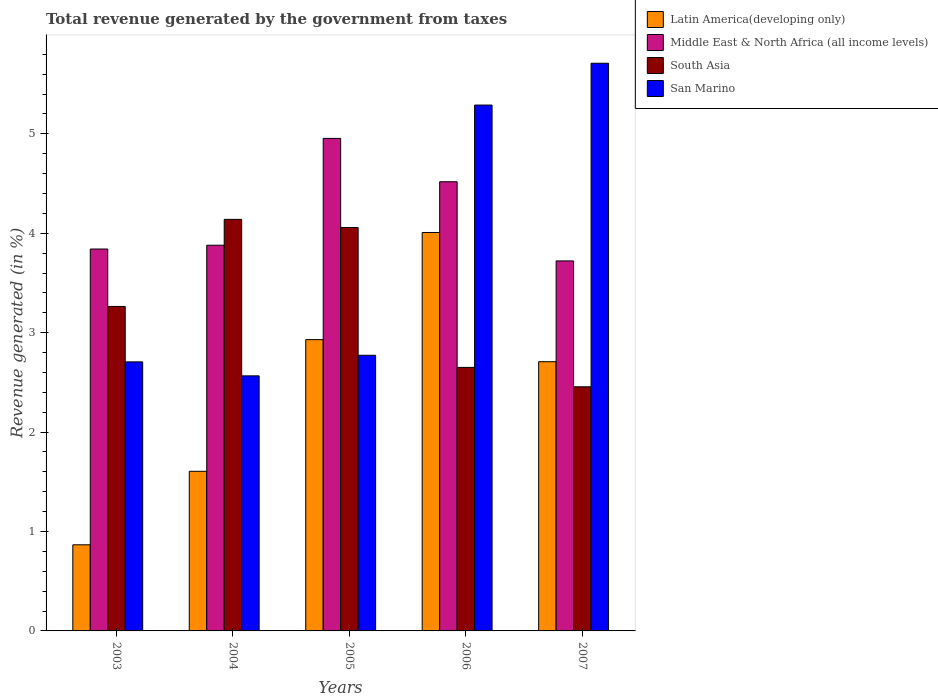How many different coloured bars are there?
Give a very brief answer. 4. How many groups of bars are there?
Keep it short and to the point. 5. Are the number of bars on each tick of the X-axis equal?
Provide a succinct answer. Yes. How many bars are there on the 1st tick from the right?
Offer a very short reply. 4. What is the label of the 4th group of bars from the left?
Your answer should be very brief. 2006. What is the total revenue generated in South Asia in 2007?
Provide a succinct answer. 2.46. Across all years, what is the maximum total revenue generated in Middle East & North Africa (all income levels)?
Provide a succinct answer. 4.95. Across all years, what is the minimum total revenue generated in San Marino?
Give a very brief answer. 2.57. What is the total total revenue generated in San Marino in the graph?
Your answer should be very brief. 19.04. What is the difference between the total revenue generated in San Marino in 2006 and that in 2007?
Your answer should be compact. -0.42. What is the difference between the total revenue generated in Latin America(developing only) in 2005 and the total revenue generated in Middle East & North Africa (all income levels) in 2006?
Ensure brevity in your answer.  -1.59. What is the average total revenue generated in South Asia per year?
Your answer should be compact. 3.31. In the year 2006, what is the difference between the total revenue generated in Middle East & North Africa (all income levels) and total revenue generated in South Asia?
Provide a short and direct response. 1.87. In how many years, is the total revenue generated in South Asia greater than 3 %?
Your answer should be compact. 3. What is the ratio of the total revenue generated in South Asia in 2003 to that in 2006?
Your answer should be compact. 1.23. Is the total revenue generated in South Asia in 2006 less than that in 2007?
Provide a succinct answer. No. Is the difference between the total revenue generated in Middle East & North Africa (all income levels) in 2003 and 2007 greater than the difference between the total revenue generated in South Asia in 2003 and 2007?
Ensure brevity in your answer.  No. What is the difference between the highest and the second highest total revenue generated in Middle East & North Africa (all income levels)?
Provide a succinct answer. 0.44. What is the difference between the highest and the lowest total revenue generated in Latin America(developing only)?
Ensure brevity in your answer.  3.14. In how many years, is the total revenue generated in Latin America(developing only) greater than the average total revenue generated in Latin America(developing only) taken over all years?
Your response must be concise. 3. What does the 3rd bar from the left in 2005 represents?
Provide a short and direct response. South Asia. What does the 3rd bar from the right in 2003 represents?
Ensure brevity in your answer.  Middle East & North Africa (all income levels). Does the graph contain grids?
Ensure brevity in your answer.  No. Where does the legend appear in the graph?
Offer a very short reply. Top right. How many legend labels are there?
Keep it short and to the point. 4. How are the legend labels stacked?
Give a very brief answer. Vertical. What is the title of the graph?
Provide a succinct answer. Total revenue generated by the government from taxes. What is the label or title of the X-axis?
Provide a succinct answer. Years. What is the label or title of the Y-axis?
Ensure brevity in your answer.  Revenue generated (in %). What is the Revenue generated (in %) in Latin America(developing only) in 2003?
Ensure brevity in your answer.  0.87. What is the Revenue generated (in %) of Middle East & North Africa (all income levels) in 2003?
Offer a very short reply. 3.84. What is the Revenue generated (in %) of South Asia in 2003?
Offer a terse response. 3.26. What is the Revenue generated (in %) of San Marino in 2003?
Your response must be concise. 2.71. What is the Revenue generated (in %) in Latin America(developing only) in 2004?
Offer a very short reply. 1.61. What is the Revenue generated (in %) of Middle East & North Africa (all income levels) in 2004?
Keep it short and to the point. 3.88. What is the Revenue generated (in %) in South Asia in 2004?
Your answer should be very brief. 4.14. What is the Revenue generated (in %) in San Marino in 2004?
Make the answer very short. 2.57. What is the Revenue generated (in %) in Latin America(developing only) in 2005?
Give a very brief answer. 2.93. What is the Revenue generated (in %) in Middle East & North Africa (all income levels) in 2005?
Offer a terse response. 4.95. What is the Revenue generated (in %) in South Asia in 2005?
Keep it short and to the point. 4.06. What is the Revenue generated (in %) of San Marino in 2005?
Offer a very short reply. 2.77. What is the Revenue generated (in %) in Latin America(developing only) in 2006?
Your response must be concise. 4.01. What is the Revenue generated (in %) in Middle East & North Africa (all income levels) in 2006?
Provide a succinct answer. 4.52. What is the Revenue generated (in %) of South Asia in 2006?
Your answer should be compact. 2.65. What is the Revenue generated (in %) of San Marino in 2006?
Ensure brevity in your answer.  5.29. What is the Revenue generated (in %) of Latin America(developing only) in 2007?
Offer a terse response. 2.71. What is the Revenue generated (in %) of Middle East & North Africa (all income levels) in 2007?
Offer a very short reply. 3.72. What is the Revenue generated (in %) of South Asia in 2007?
Provide a succinct answer. 2.46. What is the Revenue generated (in %) in San Marino in 2007?
Keep it short and to the point. 5.71. Across all years, what is the maximum Revenue generated (in %) in Latin America(developing only)?
Make the answer very short. 4.01. Across all years, what is the maximum Revenue generated (in %) in Middle East & North Africa (all income levels)?
Provide a short and direct response. 4.95. Across all years, what is the maximum Revenue generated (in %) in South Asia?
Your response must be concise. 4.14. Across all years, what is the maximum Revenue generated (in %) in San Marino?
Offer a very short reply. 5.71. Across all years, what is the minimum Revenue generated (in %) of Latin America(developing only)?
Your answer should be compact. 0.87. Across all years, what is the minimum Revenue generated (in %) of Middle East & North Africa (all income levels)?
Your answer should be compact. 3.72. Across all years, what is the minimum Revenue generated (in %) in South Asia?
Your response must be concise. 2.46. Across all years, what is the minimum Revenue generated (in %) of San Marino?
Offer a terse response. 2.57. What is the total Revenue generated (in %) of Latin America(developing only) in the graph?
Give a very brief answer. 12.12. What is the total Revenue generated (in %) in Middle East & North Africa (all income levels) in the graph?
Keep it short and to the point. 20.92. What is the total Revenue generated (in %) in South Asia in the graph?
Make the answer very short. 16.57. What is the total Revenue generated (in %) in San Marino in the graph?
Give a very brief answer. 19.04. What is the difference between the Revenue generated (in %) of Latin America(developing only) in 2003 and that in 2004?
Give a very brief answer. -0.74. What is the difference between the Revenue generated (in %) of Middle East & North Africa (all income levels) in 2003 and that in 2004?
Your answer should be compact. -0.04. What is the difference between the Revenue generated (in %) in South Asia in 2003 and that in 2004?
Provide a succinct answer. -0.88. What is the difference between the Revenue generated (in %) in San Marino in 2003 and that in 2004?
Your response must be concise. 0.14. What is the difference between the Revenue generated (in %) of Latin America(developing only) in 2003 and that in 2005?
Your response must be concise. -2.06. What is the difference between the Revenue generated (in %) in Middle East & North Africa (all income levels) in 2003 and that in 2005?
Your answer should be compact. -1.11. What is the difference between the Revenue generated (in %) in South Asia in 2003 and that in 2005?
Your answer should be compact. -0.79. What is the difference between the Revenue generated (in %) of San Marino in 2003 and that in 2005?
Provide a short and direct response. -0.07. What is the difference between the Revenue generated (in %) of Latin America(developing only) in 2003 and that in 2006?
Offer a terse response. -3.14. What is the difference between the Revenue generated (in %) of Middle East & North Africa (all income levels) in 2003 and that in 2006?
Make the answer very short. -0.68. What is the difference between the Revenue generated (in %) of South Asia in 2003 and that in 2006?
Keep it short and to the point. 0.61. What is the difference between the Revenue generated (in %) of San Marino in 2003 and that in 2006?
Give a very brief answer. -2.58. What is the difference between the Revenue generated (in %) in Latin America(developing only) in 2003 and that in 2007?
Provide a short and direct response. -1.84. What is the difference between the Revenue generated (in %) of Middle East & North Africa (all income levels) in 2003 and that in 2007?
Your answer should be compact. 0.12. What is the difference between the Revenue generated (in %) of South Asia in 2003 and that in 2007?
Your answer should be very brief. 0.81. What is the difference between the Revenue generated (in %) in San Marino in 2003 and that in 2007?
Your response must be concise. -3. What is the difference between the Revenue generated (in %) in Latin America(developing only) in 2004 and that in 2005?
Offer a very short reply. -1.32. What is the difference between the Revenue generated (in %) of Middle East & North Africa (all income levels) in 2004 and that in 2005?
Ensure brevity in your answer.  -1.07. What is the difference between the Revenue generated (in %) in South Asia in 2004 and that in 2005?
Give a very brief answer. 0.08. What is the difference between the Revenue generated (in %) in San Marino in 2004 and that in 2005?
Ensure brevity in your answer.  -0.21. What is the difference between the Revenue generated (in %) in Latin America(developing only) in 2004 and that in 2006?
Make the answer very short. -2.4. What is the difference between the Revenue generated (in %) in Middle East & North Africa (all income levels) in 2004 and that in 2006?
Make the answer very short. -0.64. What is the difference between the Revenue generated (in %) of South Asia in 2004 and that in 2006?
Offer a very short reply. 1.49. What is the difference between the Revenue generated (in %) in San Marino in 2004 and that in 2006?
Keep it short and to the point. -2.72. What is the difference between the Revenue generated (in %) in Latin America(developing only) in 2004 and that in 2007?
Ensure brevity in your answer.  -1.1. What is the difference between the Revenue generated (in %) of Middle East & North Africa (all income levels) in 2004 and that in 2007?
Offer a very short reply. 0.16. What is the difference between the Revenue generated (in %) of South Asia in 2004 and that in 2007?
Keep it short and to the point. 1.68. What is the difference between the Revenue generated (in %) of San Marino in 2004 and that in 2007?
Offer a very short reply. -3.14. What is the difference between the Revenue generated (in %) in Latin America(developing only) in 2005 and that in 2006?
Make the answer very short. -1.08. What is the difference between the Revenue generated (in %) in Middle East & North Africa (all income levels) in 2005 and that in 2006?
Your answer should be compact. 0.44. What is the difference between the Revenue generated (in %) of South Asia in 2005 and that in 2006?
Your answer should be very brief. 1.41. What is the difference between the Revenue generated (in %) of San Marino in 2005 and that in 2006?
Your answer should be very brief. -2.52. What is the difference between the Revenue generated (in %) in Latin America(developing only) in 2005 and that in 2007?
Give a very brief answer. 0.22. What is the difference between the Revenue generated (in %) in Middle East & North Africa (all income levels) in 2005 and that in 2007?
Your answer should be very brief. 1.23. What is the difference between the Revenue generated (in %) of South Asia in 2005 and that in 2007?
Keep it short and to the point. 1.6. What is the difference between the Revenue generated (in %) in San Marino in 2005 and that in 2007?
Offer a terse response. -2.94. What is the difference between the Revenue generated (in %) in Latin America(developing only) in 2006 and that in 2007?
Keep it short and to the point. 1.3. What is the difference between the Revenue generated (in %) of Middle East & North Africa (all income levels) in 2006 and that in 2007?
Your answer should be compact. 0.8. What is the difference between the Revenue generated (in %) in South Asia in 2006 and that in 2007?
Offer a terse response. 0.2. What is the difference between the Revenue generated (in %) of San Marino in 2006 and that in 2007?
Offer a very short reply. -0.42. What is the difference between the Revenue generated (in %) of Latin America(developing only) in 2003 and the Revenue generated (in %) of Middle East & North Africa (all income levels) in 2004?
Ensure brevity in your answer.  -3.01. What is the difference between the Revenue generated (in %) of Latin America(developing only) in 2003 and the Revenue generated (in %) of South Asia in 2004?
Provide a short and direct response. -3.27. What is the difference between the Revenue generated (in %) in Latin America(developing only) in 2003 and the Revenue generated (in %) in San Marino in 2004?
Ensure brevity in your answer.  -1.7. What is the difference between the Revenue generated (in %) of Middle East & North Africa (all income levels) in 2003 and the Revenue generated (in %) of South Asia in 2004?
Provide a short and direct response. -0.3. What is the difference between the Revenue generated (in %) in Middle East & North Africa (all income levels) in 2003 and the Revenue generated (in %) in San Marino in 2004?
Make the answer very short. 1.28. What is the difference between the Revenue generated (in %) of South Asia in 2003 and the Revenue generated (in %) of San Marino in 2004?
Your answer should be compact. 0.7. What is the difference between the Revenue generated (in %) of Latin America(developing only) in 2003 and the Revenue generated (in %) of Middle East & North Africa (all income levels) in 2005?
Your answer should be compact. -4.09. What is the difference between the Revenue generated (in %) of Latin America(developing only) in 2003 and the Revenue generated (in %) of South Asia in 2005?
Provide a succinct answer. -3.19. What is the difference between the Revenue generated (in %) in Latin America(developing only) in 2003 and the Revenue generated (in %) in San Marino in 2005?
Your answer should be compact. -1.91. What is the difference between the Revenue generated (in %) in Middle East & North Africa (all income levels) in 2003 and the Revenue generated (in %) in South Asia in 2005?
Provide a succinct answer. -0.22. What is the difference between the Revenue generated (in %) in Middle East & North Africa (all income levels) in 2003 and the Revenue generated (in %) in San Marino in 2005?
Your response must be concise. 1.07. What is the difference between the Revenue generated (in %) in South Asia in 2003 and the Revenue generated (in %) in San Marino in 2005?
Ensure brevity in your answer.  0.49. What is the difference between the Revenue generated (in %) of Latin America(developing only) in 2003 and the Revenue generated (in %) of Middle East & North Africa (all income levels) in 2006?
Provide a short and direct response. -3.65. What is the difference between the Revenue generated (in %) of Latin America(developing only) in 2003 and the Revenue generated (in %) of South Asia in 2006?
Give a very brief answer. -1.78. What is the difference between the Revenue generated (in %) in Latin America(developing only) in 2003 and the Revenue generated (in %) in San Marino in 2006?
Offer a terse response. -4.42. What is the difference between the Revenue generated (in %) of Middle East & North Africa (all income levels) in 2003 and the Revenue generated (in %) of South Asia in 2006?
Keep it short and to the point. 1.19. What is the difference between the Revenue generated (in %) of Middle East & North Africa (all income levels) in 2003 and the Revenue generated (in %) of San Marino in 2006?
Make the answer very short. -1.45. What is the difference between the Revenue generated (in %) in South Asia in 2003 and the Revenue generated (in %) in San Marino in 2006?
Ensure brevity in your answer.  -2.03. What is the difference between the Revenue generated (in %) of Latin America(developing only) in 2003 and the Revenue generated (in %) of Middle East & North Africa (all income levels) in 2007?
Ensure brevity in your answer.  -2.86. What is the difference between the Revenue generated (in %) of Latin America(developing only) in 2003 and the Revenue generated (in %) of South Asia in 2007?
Offer a terse response. -1.59. What is the difference between the Revenue generated (in %) of Latin America(developing only) in 2003 and the Revenue generated (in %) of San Marino in 2007?
Make the answer very short. -4.84. What is the difference between the Revenue generated (in %) of Middle East & North Africa (all income levels) in 2003 and the Revenue generated (in %) of South Asia in 2007?
Ensure brevity in your answer.  1.39. What is the difference between the Revenue generated (in %) of Middle East & North Africa (all income levels) in 2003 and the Revenue generated (in %) of San Marino in 2007?
Your answer should be very brief. -1.87. What is the difference between the Revenue generated (in %) of South Asia in 2003 and the Revenue generated (in %) of San Marino in 2007?
Your response must be concise. -2.45. What is the difference between the Revenue generated (in %) in Latin America(developing only) in 2004 and the Revenue generated (in %) in Middle East & North Africa (all income levels) in 2005?
Your answer should be very brief. -3.35. What is the difference between the Revenue generated (in %) of Latin America(developing only) in 2004 and the Revenue generated (in %) of South Asia in 2005?
Provide a short and direct response. -2.45. What is the difference between the Revenue generated (in %) of Latin America(developing only) in 2004 and the Revenue generated (in %) of San Marino in 2005?
Make the answer very short. -1.17. What is the difference between the Revenue generated (in %) in Middle East & North Africa (all income levels) in 2004 and the Revenue generated (in %) in South Asia in 2005?
Offer a very short reply. -0.18. What is the difference between the Revenue generated (in %) in Middle East & North Africa (all income levels) in 2004 and the Revenue generated (in %) in San Marino in 2005?
Give a very brief answer. 1.11. What is the difference between the Revenue generated (in %) of South Asia in 2004 and the Revenue generated (in %) of San Marino in 2005?
Provide a succinct answer. 1.37. What is the difference between the Revenue generated (in %) of Latin America(developing only) in 2004 and the Revenue generated (in %) of Middle East & North Africa (all income levels) in 2006?
Your answer should be very brief. -2.91. What is the difference between the Revenue generated (in %) of Latin America(developing only) in 2004 and the Revenue generated (in %) of South Asia in 2006?
Keep it short and to the point. -1.05. What is the difference between the Revenue generated (in %) of Latin America(developing only) in 2004 and the Revenue generated (in %) of San Marino in 2006?
Keep it short and to the point. -3.68. What is the difference between the Revenue generated (in %) in Middle East & North Africa (all income levels) in 2004 and the Revenue generated (in %) in South Asia in 2006?
Provide a short and direct response. 1.23. What is the difference between the Revenue generated (in %) of Middle East & North Africa (all income levels) in 2004 and the Revenue generated (in %) of San Marino in 2006?
Make the answer very short. -1.41. What is the difference between the Revenue generated (in %) of South Asia in 2004 and the Revenue generated (in %) of San Marino in 2006?
Your response must be concise. -1.15. What is the difference between the Revenue generated (in %) in Latin America(developing only) in 2004 and the Revenue generated (in %) in Middle East & North Africa (all income levels) in 2007?
Your answer should be compact. -2.12. What is the difference between the Revenue generated (in %) of Latin America(developing only) in 2004 and the Revenue generated (in %) of South Asia in 2007?
Give a very brief answer. -0.85. What is the difference between the Revenue generated (in %) of Latin America(developing only) in 2004 and the Revenue generated (in %) of San Marino in 2007?
Offer a terse response. -4.1. What is the difference between the Revenue generated (in %) in Middle East & North Africa (all income levels) in 2004 and the Revenue generated (in %) in South Asia in 2007?
Give a very brief answer. 1.42. What is the difference between the Revenue generated (in %) of Middle East & North Africa (all income levels) in 2004 and the Revenue generated (in %) of San Marino in 2007?
Offer a very short reply. -1.83. What is the difference between the Revenue generated (in %) of South Asia in 2004 and the Revenue generated (in %) of San Marino in 2007?
Keep it short and to the point. -1.57. What is the difference between the Revenue generated (in %) in Latin America(developing only) in 2005 and the Revenue generated (in %) in Middle East & North Africa (all income levels) in 2006?
Provide a succinct answer. -1.59. What is the difference between the Revenue generated (in %) of Latin America(developing only) in 2005 and the Revenue generated (in %) of South Asia in 2006?
Your answer should be very brief. 0.28. What is the difference between the Revenue generated (in %) of Latin America(developing only) in 2005 and the Revenue generated (in %) of San Marino in 2006?
Make the answer very short. -2.36. What is the difference between the Revenue generated (in %) in Middle East & North Africa (all income levels) in 2005 and the Revenue generated (in %) in South Asia in 2006?
Provide a short and direct response. 2.3. What is the difference between the Revenue generated (in %) of Middle East & North Africa (all income levels) in 2005 and the Revenue generated (in %) of San Marino in 2006?
Your response must be concise. -0.34. What is the difference between the Revenue generated (in %) in South Asia in 2005 and the Revenue generated (in %) in San Marino in 2006?
Your answer should be very brief. -1.23. What is the difference between the Revenue generated (in %) in Latin America(developing only) in 2005 and the Revenue generated (in %) in Middle East & North Africa (all income levels) in 2007?
Ensure brevity in your answer.  -0.79. What is the difference between the Revenue generated (in %) of Latin America(developing only) in 2005 and the Revenue generated (in %) of South Asia in 2007?
Give a very brief answer. 0.47. What is the difference between the Revenue generated (in %) in Latin America(developing only) in 2005 and the Revenue generated (in %) in San Marino in 2007?
Your response must be concise. -2.78. What is the difference between the Revenue generated (in %) in Middle East & North Africa (all income levels) in 2005 and the Revenue generated (in %) in South Asia in 2007?
Make the answer very short. 2.5. What is the difference between the Revenue generated (in %) of Middle East & North Africa (all income levels) in 2005 and the Revenue generated (in %) of San Marino in 2007?
Give a very brief answer. -0.76. What is the difference between the Revenue generated (in %) of South Asia in 2005 and the Revenue generated (in %) of San Marino in 2007?
Ensure brevity in your answer.  -1.65. What is the difference between the Revenue generated (in %) of Latin America(developing only) in 2006 and the Revenue generated (in %) of Middle East & North Africa (all income levels) in 2007?
Offer a very short reply. 0.29. What is the difference between the Revenue generated (in %) of Latin America(developing only) in 2006 and the Revenue generated (in %) of South Asia in 2007?
Make the answer very short. 1.55. What is the difference between the Revenue generated (in %) of Latin America(developing only) in 2006 and the Revenue generated (in %) of San Marino in 2007?
Keep it short and to the point. -1.7. What is the difference between the Revenue generated (in %) of Middle East & North Africa (all income levels) in 2006 and the Revenue generated (in %) of South Asia in 2007?
Ensure brevity in your answer.  2.06. What is the difference between the Revenue generated (in %) in Middle East & North Africa (all income levels) in 2006 and the Revenue generated (in %) in San Marino in 2007?
Your answer should be very brief. -1.19. What is the difference between the Revenue generated (in %) in South Asia in 2006 and the Revenue generated (in %) in San Marino in 2007?
Keep it short and to the point. -3.06. What is the average Revenue generated (in %) in Latin America(developing only) per year?
Ensure brevity in your answer.  2.42. What is the average Revenue generated (in %) in Middle East & North Africa (all income levels) per year?
Ensure brevity in your answer.  4.18. What is the average Revenue generated (in %) of South Asia per year?
Keep it short and to the point. 3.31. What is the average Revenue generated (in %) of San Marino per year?
Your answer should be compact. 3.81. In the year 2003, what is the difference between the Revenue generated (in %) in Latin America(developing only) and Revenue generated (in %) in Middle East & North Africa (all income levels)?
Make the answer very short. -2.98. In the year 2003, what is the difference between the Revenue generated (in %) in Latin America(developing only) and Revenue generated (in %) in South Asia?
Provide a short and direct response. -2.4. In the year 2003, what is the difference between the Revenue generated (in %) in Latin America(developing only) and Revenue generated (in %) in San Marino?
Make the answer very short. -1.84. In the year 2003, what is the difference between the Revenue generated (in %) of Middle East & North Africa (all income levels) and Revenue generated (in %) of South Asia?
Provide a succinct answer. 0.58. In the year 2003, what is the difference between the Revenue generated (in %) in Middle East & North Africa (all income levels) and Revenue generated (in %) in San Marino?
Offer a terse response. 1.14. In the year 2003, what is the difference between the Revenue generated (in %) of South Asia and Revenue generated (in %) of San Marino?
Your answer should be compact. 0.56. In the year 2004, what is the difference between the Revenue generated (in %) of Latin America(developing only) and Revenue generated (in %) of Middle East & North Africa (all income levels)?
Your response must be concise. -2.27. In the year 2004, what is the difference between the Revenue generated (in %) in Latin America(developing only) and Revenue generated (in %) in South Asia?
Your answer should be very brief. -2.53. In the year 2004, what is the difference between the Revenue generated (in %) in Latin America(developing only) and Revenue generated (in %) in San Marino?
Your response must be concise. -0.96. In the year 2004, what is the difference between the Revenue generated (in %) in Middle East & North Africa (all income levels) and Revenue generated (in %) in South Asia?
Provide a succinct answer. -0.26. In the year 2004, what is the difference between the Revenue generated (in %) of Middle East & North Africa (all income levels) and Revenue generated (in %) of San Marino?
Ensure brevity in your answer.  1.31. In the year 2004, what is the difference between the Revenue generated (in %) of South Asia and Revenue generated (in %) of San Marino?
Provide a short and direct response. 1.57. In the year 2005, what is the difference between the Revenue generated (in %) in Latin America(developing only) and Revenue generated (in %) in Middle East & North Africa (all income levels)?
Provide a succinct answer. -2.02. In the year 2005, what is the difference between the Revenue generated (in %) in Latin America(developing only) and Revenue generated (in %) in South Asia?
Ensure brevity in your answer.  -1.13. In the year 2005, what is the difference between the Revenue generated (in %) in Latin America(developing only) and Revenue generated (in %) in San Marino?
Make the answer very short. 0.16. In the year 2005, what is the difference between the Revenue generated (in %) of Middle East & North Africa (all income levels) and Revenue generated (in %) of South Asia?
Offer a very short reply. 0.9. In the year 2005, what is the difference between the Revenue generated (in %) of Middle East & North Africa (all income levels) and Revenue generated (in %) of San Marino?
Your answer should be compact. 2.18. In the year 2005, what is the difference between the Revenue generated (in %) of South Asia and Revenue generated (in %) of San Marino?
Keep it short and to the point. 1.29. In the year 2006, what is the difference between the Revenue generated (in %) of Latin America(developing only) and Revenue generated (in %) of Middle East & North Africa (all income levels)?
Your answer should be compact. -0.51. In the year 2006, what is the difference between the Revenue generated (in %) in Latin America(developing only) and Revenue generated (in %) in South Asia?
Give a very brief answer. 1.36. In the year 2006, what is the difference between the Revenue generated (in %) in Latin America(developing only) and Revenue generated (in %) in San Marino?
Offer a terse response. -1.28. In the year 2006, what is the difference between the Revenue generated (in %) of Middle East & North Africa (all income levels) and Revenue generated (in %) of South Asia?
Provide a succinct answer. 1.87. In the year 2006, what is the difference between the Revenue generated (in %) in Middle East & North Africa (all income levels) and Revenue generated (in %) in San Marino?
Offer a terse response. -0.77. In the year 2006, what is the difference between the Revenue generated (in %) in South Asia and Revenue generated (in %) in San Marino?
Offer a very short reply. -2.64. In the year 2007, what is the difference between the Revenue generated (in %) of Latin America(developing only) and Revenue generated (in %) of Middle East & North Africa (all income levels)?
Keep it short and to the point. -1.01. In the year 2007, what is the difference between the Revenue generated (in %) of Latin America(developing only) and Revenue generated (in %) of South Asia?
Keep it short and to the point. 0.25. In the year 2007, what is the difference between the Revenue generated (in %) of Latin America(developing only) and Revenue generated (in %) of San Marino?
Keep it short and to the point. -3. In the year 2007, what is the difference between the Revenue generated (in %) of Middle East & North Africa (all income levels) and Revenue generated (in %) of South Asia?
Give a very brief answer. 1.27. In the year 2007, what is the difference between the Revenue generated (in %) of Middle East & North Africa (all income levels) and Revenue generated (in %) of San Marino?
Offer a very short reply. -1.99. In the year 2007, what is the difference between the Revenue generated (in %) of South Asia and Revenue generated (in %) of San Marino?
Provide a succinct answer. -3.25. What is the ratio of the Revenue generated (in %) of Latin America(developing only) in 2003 to that in 2004?
Provide a succinct answer. 0.54. What is the ratio of the Revenue generated (in %) of Middle East & North Africa (all income levels) in 2003 to that in 2004?
Your response must be concise. 0.99. What is the ratio of the Revenue generated (in %) in South Asia in 2003 to that in 2004?
Your answer should be very brief. 0.79. What is the ratio of the Revenue generated (in %) in San Marino in 2003 to that in 2004?
Make the answer very short. 1.05. What is the ratio of the Revenue generated (in %) of Latin America(developing only) in 2003 to that in 2005?
Give a very brief answer. 0.3. What is the ratio of the Revenue generated (in %) in Middle East & North Africa (all income levels) in 2003 to that in 2005?
Keep it short and to the point. 0.78. What is the ratio of the Revenue generated (in %) in South Asia in 2003 to that in 2005?
Your response must be concise. 0.8. What is the ratio of the Revenue generated (in %) of San Marino in 2003 to that in 2005?
Provide a succinct answer. 0.98. What is the ratio of the Revenue generated (in %) of Latin America(developing only) in 2003 to that in 2006?
Give a very brief answer. 0.22. What is the ratio of the Revenue generated (in %) in Middle East & North Africa (all income levels) in 2003 to that in 2006?
Provide a succinct answer. 0.85. What is the ratio of the Revenue generated (in %) of South Asia in 2003 to that in 2006?
Ensure brevity in your answer.  1.23. What is the ratio of the Revenue generated (in %) in San Marino in 2003 to that in 2006?
Provide a short and direct response. 0.51. What is the ratio of the Revenue generated (in %) in Latin America(developing only) in 2003 to that in 2007?
Offer a very short reply. 0.32. What is the ratio of the Revenue generated (in %) in Middle East & North Africa (all income levels) in 2003 to that in 2007?
Provide a short and direct response. 1.03. What is the ratio of the Revenue generated (in %) of South Asia in 2003 to that in 2007?
Your answer should be very brief. 1.33. What is the ratio of the Revenue generated (in %) in San Marino in 2003 to that in 2007?
Keep it short and to the point. 0.47. What is the ratio of the Revenue generated (in %) in Latin America(developing only) in 2004 to that in 2005?
Offer a terse response. 0.55. What is the ratio of the Revenue generated (in %) in Middle East & North Africa (all income levels) in 2004 to that in 2005?
Your response must be concise. 0.78. What is the ratio of the Revenue generated (in %) of South Asia in 2004 to that in 2005?
Your response must be concise. 1.02. What is the ratio of the Revenue generated (in %) of San Marino in 2004 to that in 2005?
Offer a terse response. 0.93. What is the ratio of the Revenue generated (in %) in Latin America(developing only) in 2004 to that in 2006?
Ensure brevity in your answer.  0.4. What is the ratio of the Revenue generated (in %) in Middle East & North Africa (all income levels) in 2004 to that in 2006?
Provide a succinct answer. 0.86. What is the ratio of the Revenue generated (in %) of South Asia in 2004 to that in 2006?
Your answer should be very brief. 1.56. What is the ratio of the Revenue generated (in %) in San Marino in 2004 to that in 2006?
Your answer should be compact. 0.48. What is the ratio of the Revenue generated (in %) of Latin America(developing only) in 2004 to that in 2007?
Give a very brief answer. 0.59. What is the ratio of the Revenue generated (in %) in Middle East & North Africa (all income levels) in 2004 to that in 2007?
Ensure brevity in your answer.  1.04. What is the ratio of the Revenue generated (in %) of South Asia in 2004 to that in 2007?
Offer a terse response. 1.69. What is the ratio of the Revenue generated (in %) of San Marino in 2004 to that in 2007?
Your answer should be very brief. 0.45. What is the ratio of the Revenue generated (in %) of Latin America(developing only) in 2005 to that in 2006?
Provide a succinct answer. 0.73. What is the ratio of the Revenue generated (in %) in Middle East & North Africa (all income levels) in 2005 to that in 2006?
Your answer should be compact. 1.1. What is the ratio of the Revenue generated (in %) of South Asia in 2005 to that in 2006?
Make the answer very short. 1.53. What is the ratio of the Revenue generated (in %) in San Marino in 2005 to that in 2006?
Make the answer very short. 0.52. What is the ratio of the Revenue generated (in %) of Latin America(developing only) in 2005 to that in 2007?
Keep it short and to the point. 1.08. What is the ratio of the Revenue generated (in %) in Middle East & North Africa (all income levels) in 2005 to that in 2007?
Your answer should be compact. 1.33. What is the ratio of the Revenue generated (in %) of South Asia in 2005 to that in 2007?
Ensure brevity in your answer.  1.65. What is the ratio of the Revenue generated (in %) of San Marino in 2005 to that in 2007?
Your answer should be compact. 0.49. What is the ratio of the Revenue generated (in %) of Latin America(developing only) in 2006 to that in 2007?
Ensure brevity in your answer.  1.48. What is the ratio of the Revenue generated (in %) of Middle East & North Africa (all income levels) in 2006 to that in 2007?
Provide a short and direct response. 1.21. What is the ratio of the Revenue generated (in %) in South Asia in 2006 to that in 2007?
Provide a short and direct response. 1.08. What is the ratio of the Revenue generated (in %) in San Marino in 2006 to that in 2007?
Your response must be concise. 0.93. What is the difference between the highest and the second highest Revenue generated (in %) in Latin America(developing only)?
Your answer should be very brief. 1.08. What is the difference between the highest and the second highest Revenue generated (in %) of Middle East & North Africa (all income levels)?
Your answer should be compact. 0.44. What is the difference between the highest and the second highest Revenue generated (in %) of South Asia?
Give a very brief answer. 0.08. What is the difference between the highest and the second highest Revenue generated (in %) of San Marino?
Ensure brevity in your answer.  0.42. What is the difference between the highest and the lowest Revenue generated (in %) of Latin America(developing only)?
Give a very brief answer. 3.14. What is the difference between the highest and the lowest Revenue generated (in %) in Middle East & North Africa (all income levels)?
Provide a short and direct response. 1.23. What is the difference between the highest and the lowest Revenue generated (in %) in South Asia?
Provide a succinct answer. 1.68. What is the difference between the highest and the lowest Revenue generated (in %) of San Marino?
Your response must be concise. 3.14. 